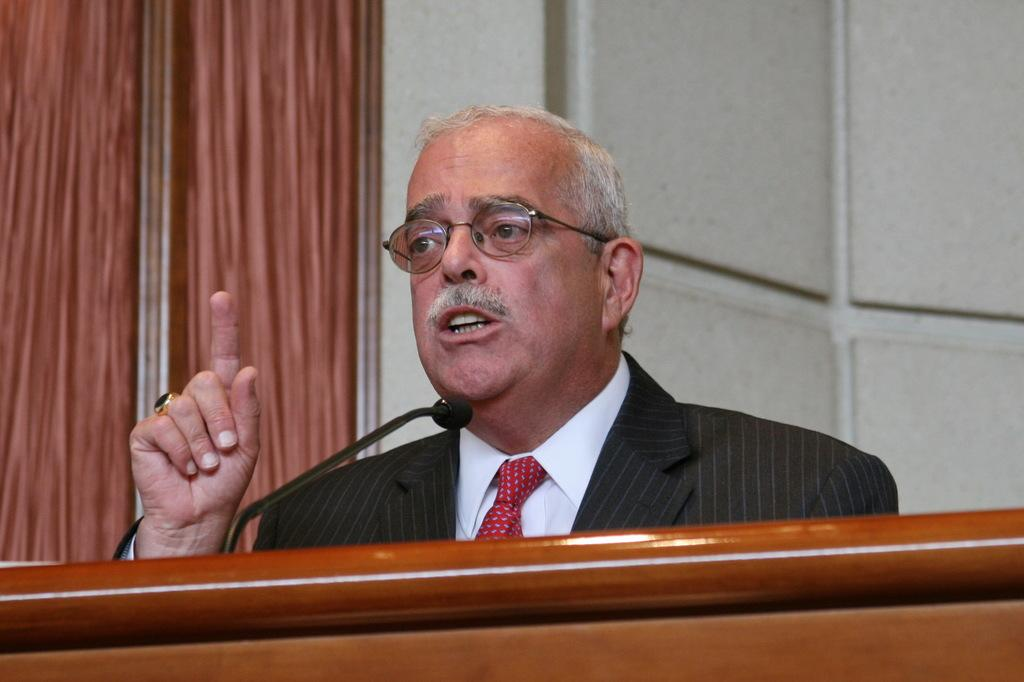What is the main subject of the image? There is a person in the image. What can be observed about the person's appearance? The person is wearing specs and a black suit. What is the person doing in the image? The person is speaking. What is present in front of the person to aid in their speech? There is a mic in front of the person. What else is in front of the person? There is a stand in front of the person. What can be seen in the background of the image? There is a wall in the background of the image. What type of coal is being used to fuel the person's speech in the image? There is no coal present in the image, and therefore it cannot be used to fuel the person's speech. What kind of oatmeal is being served on the stand in front of the person? There is no oatmeal present in the image, and the stand is likely used for holding notes or other materials related to the person's speech. 